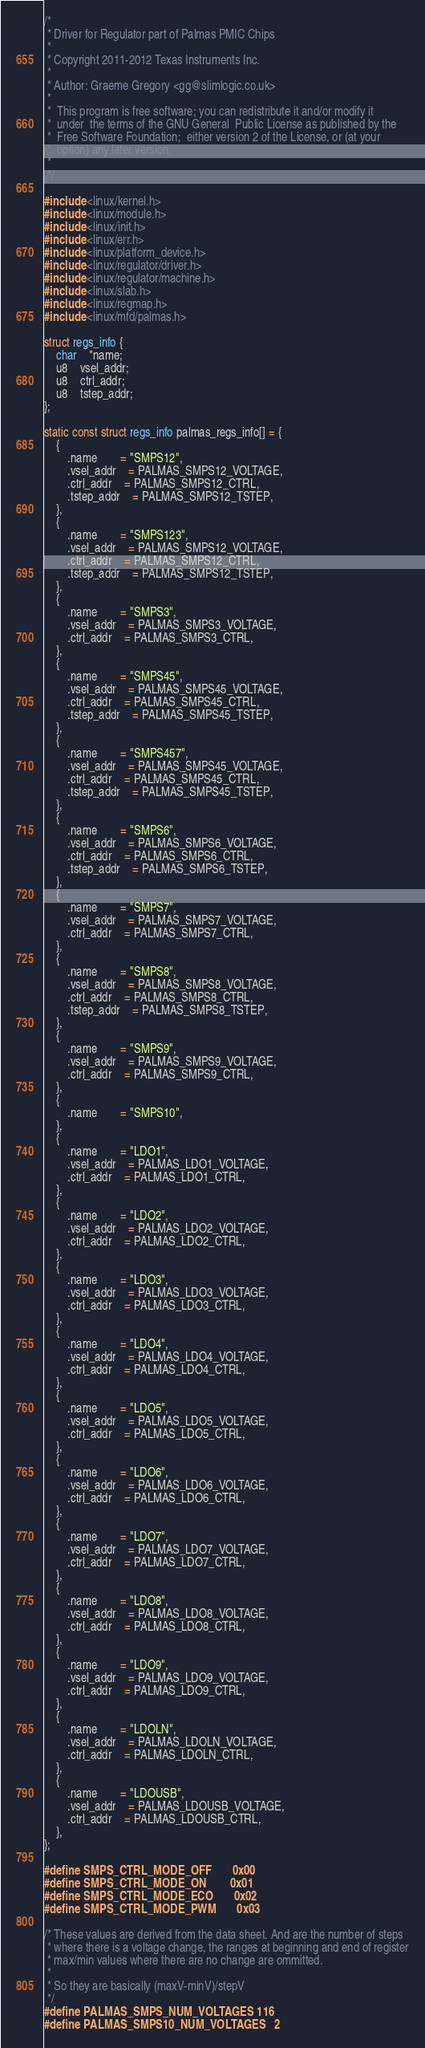Convert code to text. <code><loc_0><loc_0><loc_500><loc_500><_C_>/*
 * Driver for Regulator part of Palmas PMIC Chips
 *
 * Copyright 2011-2012 Texas Instruments Inc.
 *
 * Author: Graeme Gregory <gg@slimlogic.co.uk>
 *
 *  This program is free software; you can redistribute it and/or modify it
 *  under  the terms of the GNU General  Public License as published by the
 *  Free Software Foundation;  either version 2 of the License, or (at your
 *  option) any later version.
 *
 */

#include <linux/kernel.h>
#include <linux/module.h>
#include <linux/init.h>
#include <linux/err.h>
#include <linux/platform_device.h>
#include <linux/regulator/driver.h>
#include <linux/regulator/machine.h>
#include <linux/slab.h>
#include <linux/regmap.h>
#include <linux/mfd/palmas.h>

struct regs_info {
	char	*name;
	u8	vsel_addr;
	u8	ctrl_addr;
	u8	tstep_addr;
};

static const struct regs_info palmas_regs_info[] = {
	{
		.name		= "SMPS12",
		.vsel_addr	= PALMAS_SMPS12_VOLTAGE,
		.ctrl_addr	= PALMAS_SMPS12_CTRL,
		.tstep_addr	= PALMAS_SMPS12_TSTEP,
	},
	{
		.name		= "SMPS123",
		.vsel_addr	= PALMAS_SMPS12_VOLTAGE,
		.ctrl_addr	= PALMAS_SMPS12_CTRL,
		.tstep_addr	= PALMAS_SMPS12_TSTEP,
	},
	{
		.name		= "SMPS3",
		.vsel_addr	= PALMAS_SMPS3_VOLTAGE,
		.ctrl_addr	= PALMAS_SMPS3_CTRL,
	},
	{
		.name		= "SMPS45",
		.vsel_addr	= PALMAS_SMPS45_VOLTAGE,
		.ctrl_addr	= PALMAS_SMPS45_CTRL,
		.tstep_addr	= PALMAS_SMPS45_TSTEP,
	},
	{
		.name		= "SMPS457",
		.vsel_addr	= PALMAS_SMPS45_VOLTAGE,
		.ctrl_addr	= PALMAS_SMPS45_CTRL,
		.tstep_addr	= PALMAS_SMPS45_TSTEP,
	},
	{
		.name		= "SMPS6",
		.vsel_addr	= PALMAS_SMPS6_VOLTAGE,
		.ctrl_addr	= PALMAS_SMPS6_CTRL,
		.tstep_addr	= PALMAS_SMPS6_TSTEP,
	},
	{
		.name		= "SMPS7",
		.vsel_addr	= PALMAS_SMPS7_VOLTAGE,
		.ctrl_addr	= PALMAS_SMPS7_CTRL,
	},
	{
		.name		= "SMPS8",
		.vsel_addr	= PALMAS_SMPS8_VOLTAGE,
		.ctrl_addr	= PALMAS_SMPS8_CTRL,
		.tstep_addr	= PALMAS_SMPS8_TSTEP,
	},
	{
		.name		= "SMPS9",
		.vsel_addr	= PALMAS_SMPS9_VOLTAGE,
		.ctrl_addr	= PALMAS_SMPS9_CTRL,
	},
	{
		.name		= "SMPS10",
	},
	{
		.name		= "LDO1",
		.vsel_addr	= PALMAS_LDO1_VOLTAGE,
		.ctrl_addr	= PALMAS_LDO1_CTRL,
	},
	{
		.name		= "LDO2",
		.vsel_addr	= PALMAS_LDO2_VOLTAGE,
		.ctrl_addr	= PALMAS_LDO2_CTRL,
	},
	{
		.name		= "LDO3",
		.vsel_addr	= PALMAS_LDO3_VOLTAGE,
		.ctrl_addr	= PALMAS_LDO3_CTRL,
	},
	{
		.name		= "LDO4",
		.vsel_addr	= PALMAS_LDO4_VOLTAGE,
		.ctrl_addr	= PALMAS_LDO4_CTRL,
	},
	{
		.name		= "LDO5",
		.vsel_addr	= PALMAS_LDO5_VOLTAGE,
		.ctrl_addr	= PALMAS_LDO5_CTRL,
	},
	{
		.name		= "LDO6",
		.vsel_addr	= PALMAS_LDO6_VOLTAGE,
		.ctrl_addr	= PALMAS_LDO6_CTRL,
	},
	{
		.name		= "LDO7",
		.vsel_addr	= PALMAS_LDO7_VOLTAGE,
		.ctrl_addr	= PALMAS_LDO7_CTRL,
	},
	{
		.name		= "LDO8",
		.vsel_addr	= PALMAS_LDO8_VOLTAGE,
		.ctrl_addr	= PALMAS_LDO8_CTRL,
	},
	{
		.name		= "LDO9",
		.vsel_addr	= PALMAS_LDO9_VOLTAGE,
		.ctrl_addr	= PALMAS_LDO9_CTRL,
	},
	{
		.name		= "LDOLN",
		.vsel_addr	= PALMAS_LDOLN_VOLTAGE,
		.ctrl_addr	= PALMAS_LDOLN_CTRL,
	},
	{
		.name		= "LDOUSB",
		.vsel_addr	= PALMAS_LDOUSB_VOLTAGE,
		.ctrl_addr	= PALMAS_LDOUSB_CTRL,
	},
};

#define SMPS_CTRL_MODE_OFF		0x00
#define SMPS_CTRL_MODE_ON		0x01
#define SMPS_CTRL_MODE_ECO		0x02
#define SMPS_CTRL_MODE_PWM		0x03

/* These values are derived from the data sheet. And are the number of steps
 * where there is a voltage change, the ranges at beginning and end of register
 * max/min values where there are no change are ommitted.
 *
 * So they are basically (maxV-minV)/stepV
 */
#define PALMAS_SMPS_NUM_VOLTAGES	116
#define PALMAS_SMPS10_NUM_VOLTAGES	2</code> 